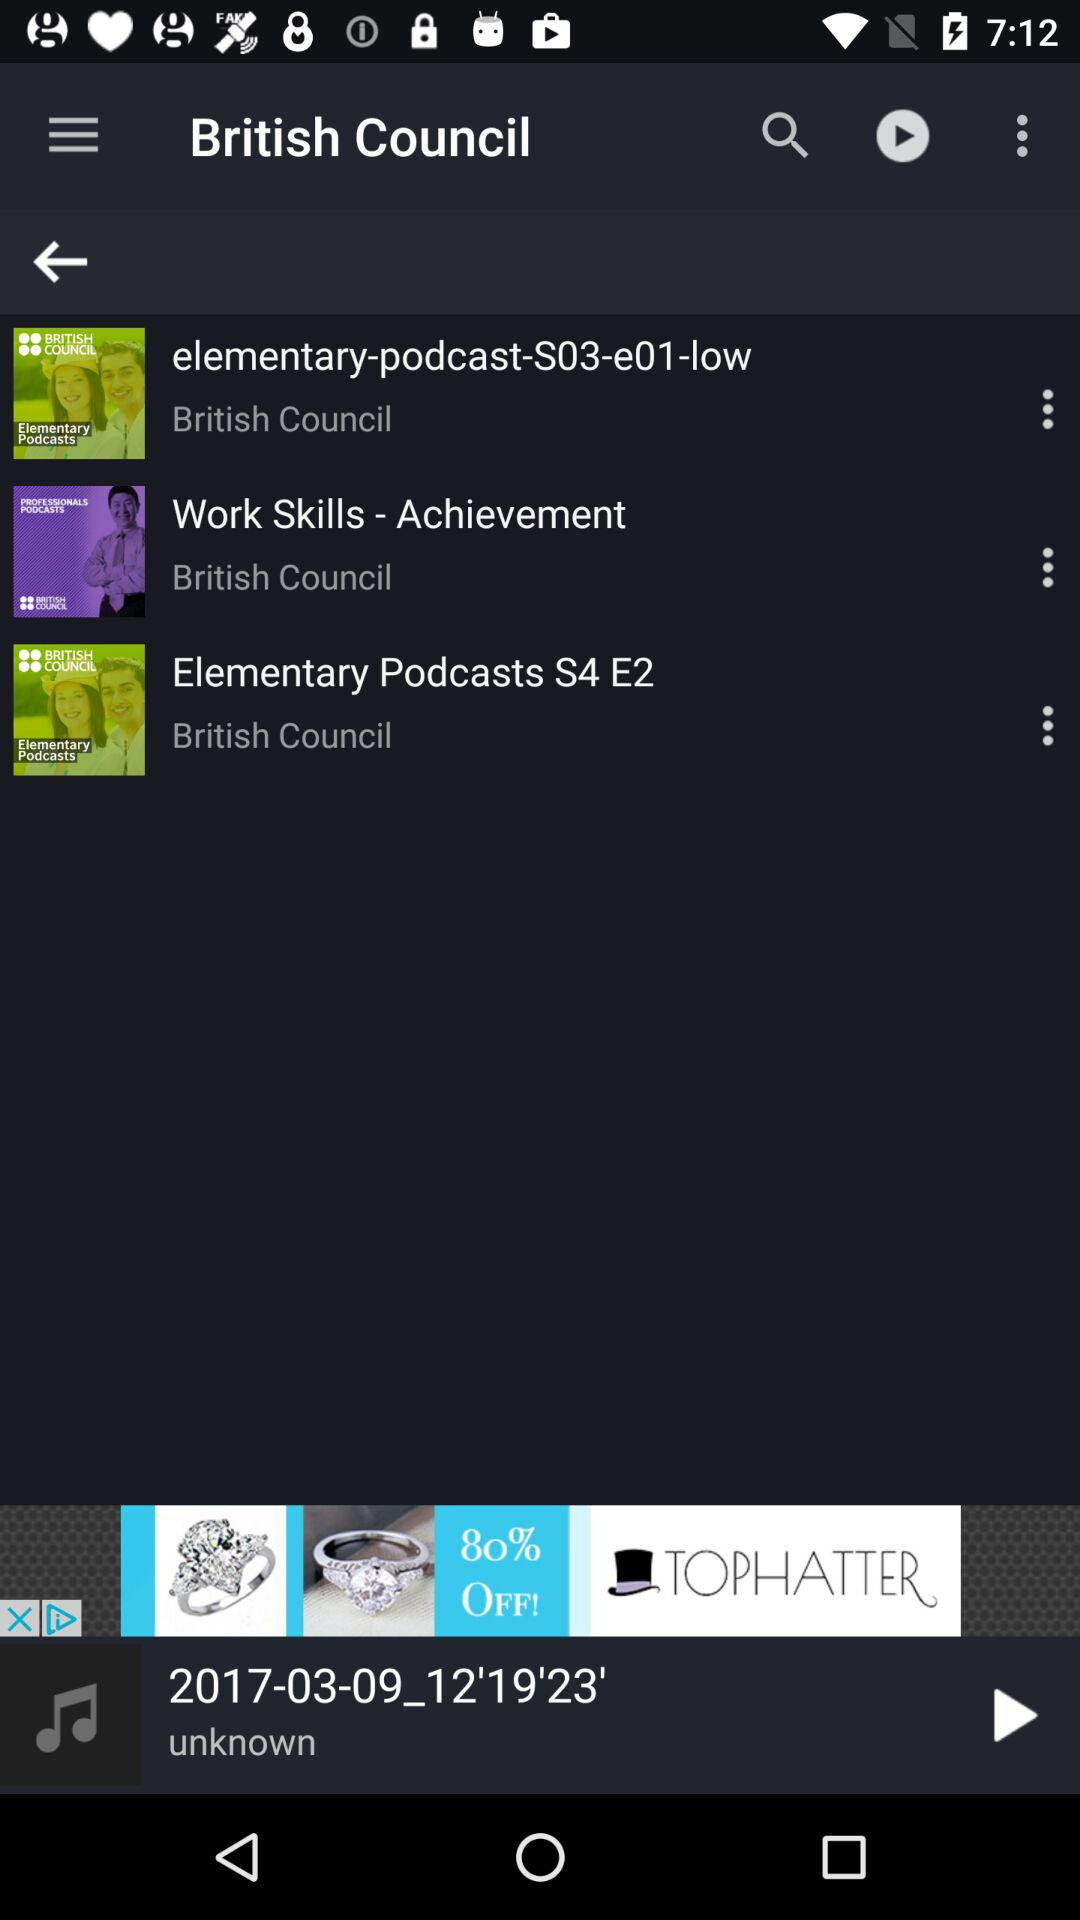Which track was last played? The last played track was "2017-03-09_12'19'23'". 